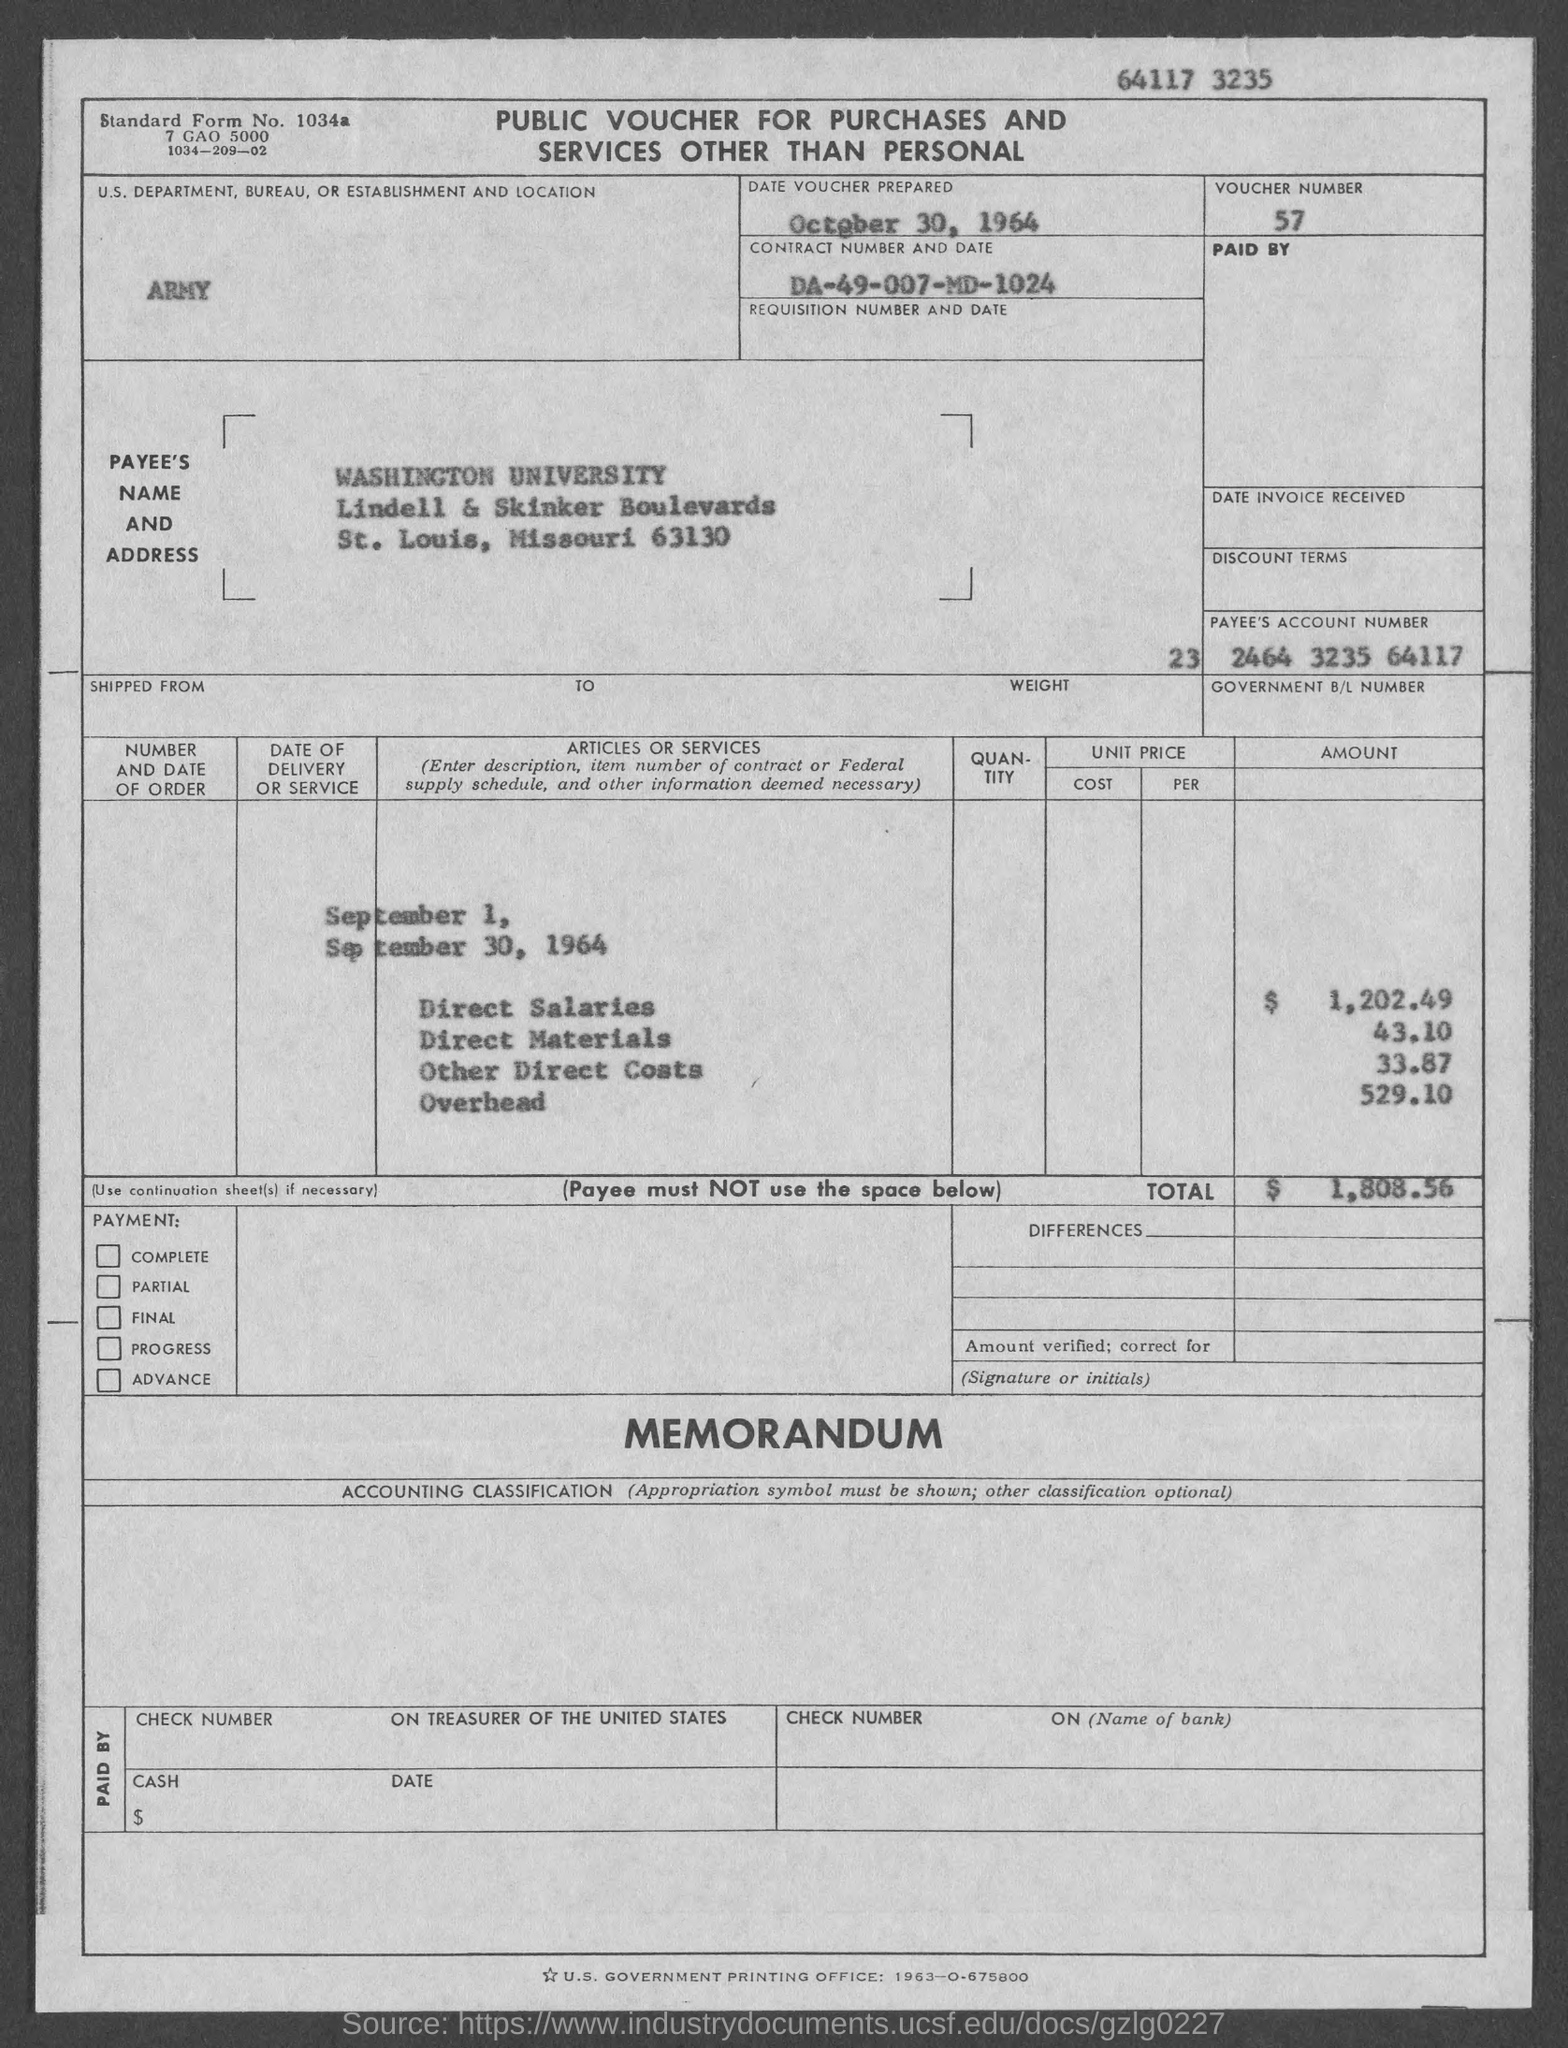Identify some key points in this picture. The standard form number is 1034a. The payee's name is Washington University. The date on which the voucher was prepared is October 30, 1964. The US Army is a department, bureau, or establishment mentioned in the voucher. The voucher number is 57. 